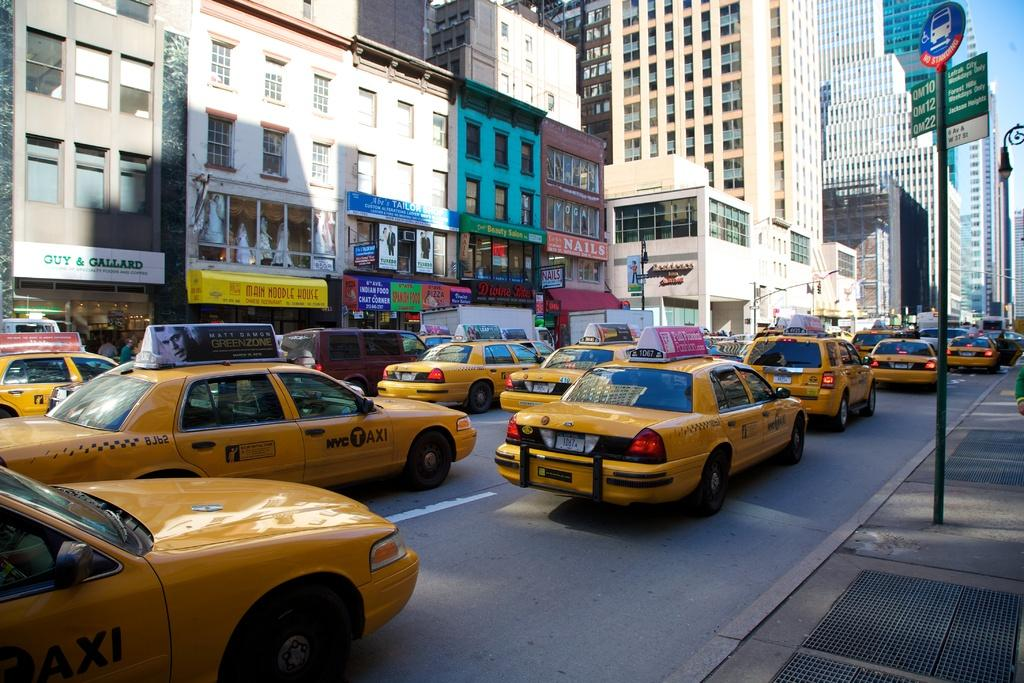What is happening on the road in the image? There are vehicles on the road in the image. What can be seen in the background of the image? There are buildings visible in the image. Are there any indicators or directions in the image? Yes, there are sign boards in the image. What type of wine is being served at the development site in the image? There is no development site or wine present in the image. How many bikes are parked near the buildings in the image? There is no mention of bikes in the image, so we cannot determine the number of bikes present. 